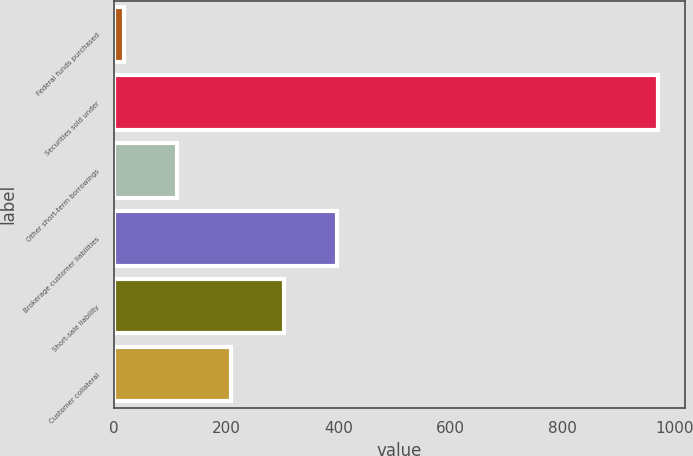Convert chart to OTSL. <chart><loc_0><loc_0><loc_500><loc_500><bar_chart><fcel>Federal funds purchased<fcel>Securities sold under<fcel>Other short-term borrowings<fcel>Brokerage customer liabilities<fcel>Short-sale liability<fcel>Customer collateral<nl><fcel>18<fcel>969<fcel>113.1<fcel>398.4<fcel>303.3<fcel>208.2<nl></chart> 